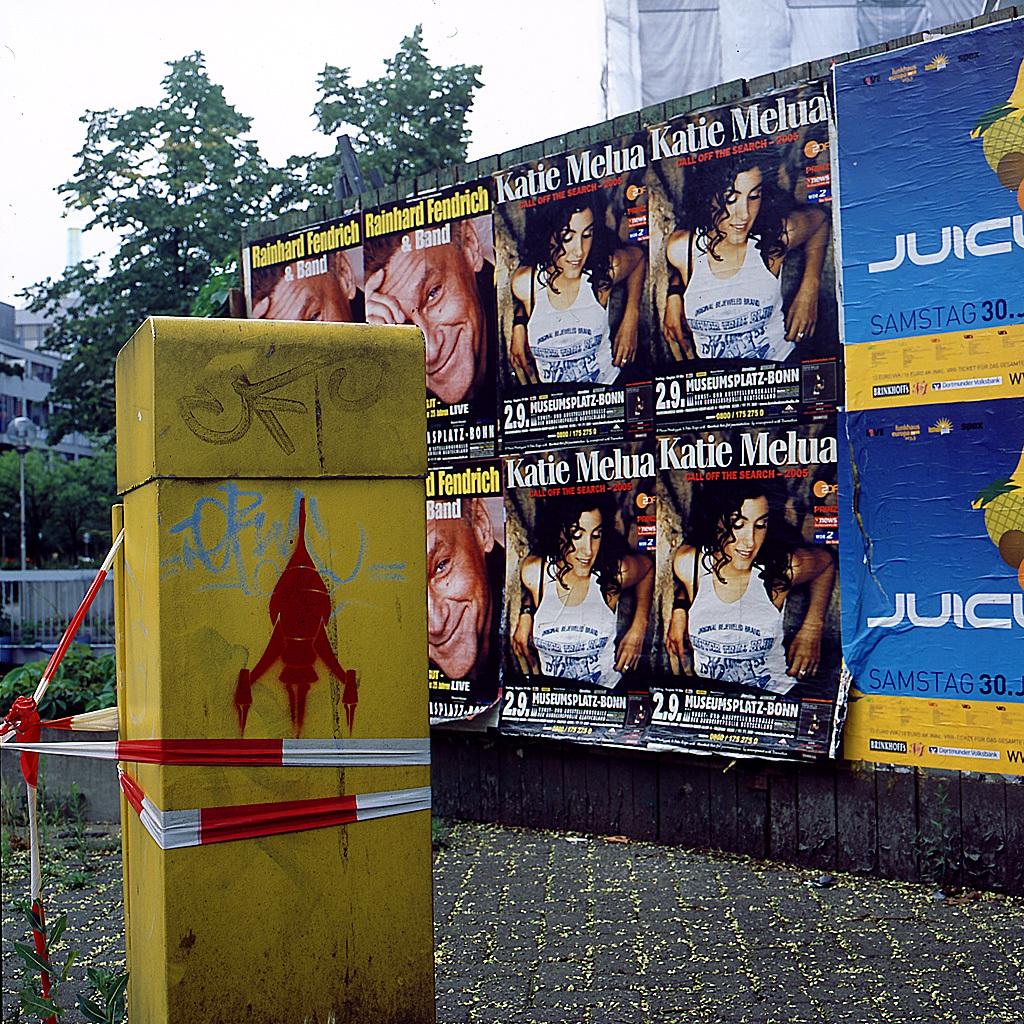Which artist is featured in the posters in the middle?
Your response must be concise. Katie melua. What 3 word graffiti is written on the top of the yellow post?
Give a very brief answer. Cko. 